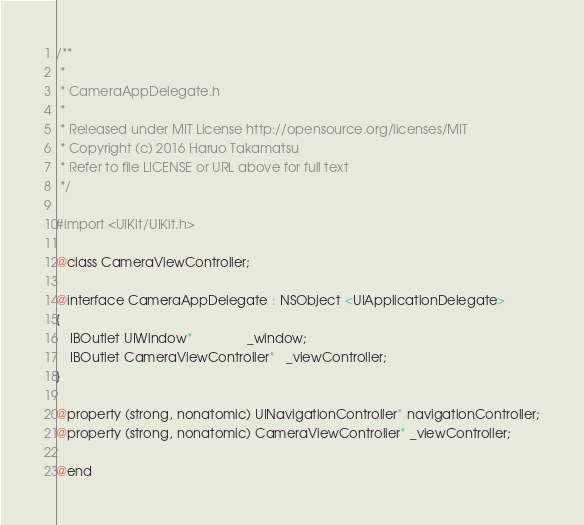Convert code to text. <code><loc_0><loc_0><loc_500><loc_500><_C_>/**
 *
 * CameraAppDelegate.h
 *
 * Released under MIT License http://opensource.org/licenses/MIT
 * Copyright (c) 2016 Haruo Takamatsu
 * Refer to file LICENSE or URL above for full text
 */

#import <UIKit/UIKit.h>

@class CameraViewController;

@interface CameraAppDelegate : NSObject <UIApplicationDelegate>
{
    IBOutlet UIWindow*               _window;
    IBOutlet CameraViewController*   _viewController;
}

@property (strong, nonatomic) UINavigationController* navigationController;
@property (strong, nonatomic) CameraViewController* _viewController;

@end</code> 